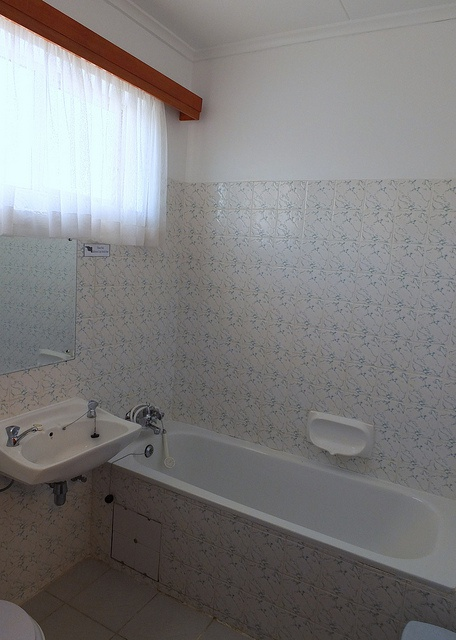Describe the objects in this image and their specific colors. I can see sink in maroon and gray tones and toilet in maroon, gray, and black tones in this image. 